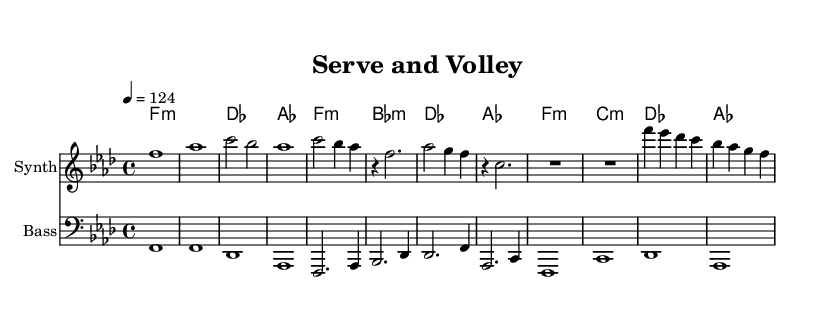What is the key signature of this music? The key signature is A flat major, which has four flats. This can be determined by identifying the key signature marking at the beginning of the staff, noting the presence of B flat, E flat, A flat, and D flat.
Answer: A flat major What is the time signature of this music? The time signature is 4/4, indicated by the fraction at the beginning of the score. This means there are four beats per measure, and the quarter note receives one beat.
Answer: 4/4 What is the tempo marking for this piece? The tempo marking is 124, shown as "4 = 124" in the tempo indication. This means the piece should be played at a speed of 124 beats per minute.
Answer: 124 How many measures are in the intro section? The intro consists of four measures, as evidenced by the distinct musical phrases present before the verse. Each element in the intro section contributes to forming these measures.
Answer: 4 Which chord is played at the beginning of the breakdown section? The chord played at the beginning of the breakdown section is F minor, which can be found by looking at the chord symbols written above the staff at the start of the breakdown.
Answer: F minor What instrument is indicated for the melody part? The instrument indicated for the melody part is "Synth," written on the staff header for that section. This designation shows what instrument should perform that particular part of the music.
Answer: Synth How do the chords progress in the verse section? The chord progression in the verse section follows this order: F minor, B flat minor, D flat major, and A flat major. This can be analyzed by looking at each measure in the verse where the chord names are placed above the melody line.
Answer: F minor, B flat minor, D flat major, A flat major 